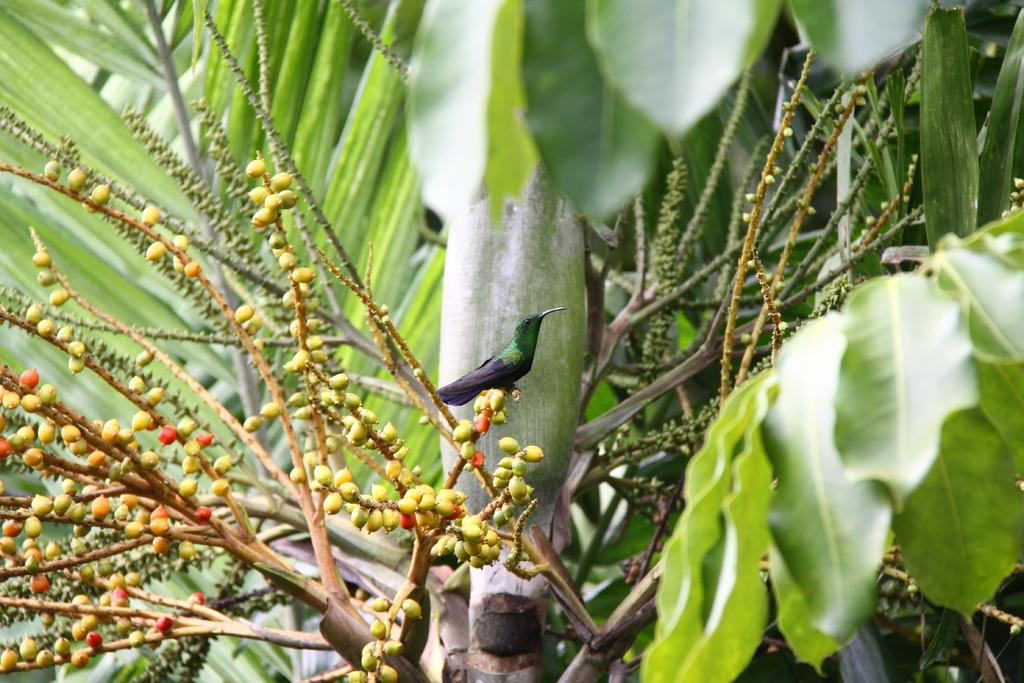What is the main subject of the image? There is a bird in the center of the image. Where is the bird located? The bird is on a tree. What can be seen in the background of the image? There are trees in the background of the image. What is present in the foreground of the image? There are fruits in the foreground of the image. What is the limit of the bird's ability to cast a cause in the image? There is no mention of a limit, casting, or cause in the image; it simply features a bird on a tree with trees in the background and fruits in the foreground. 